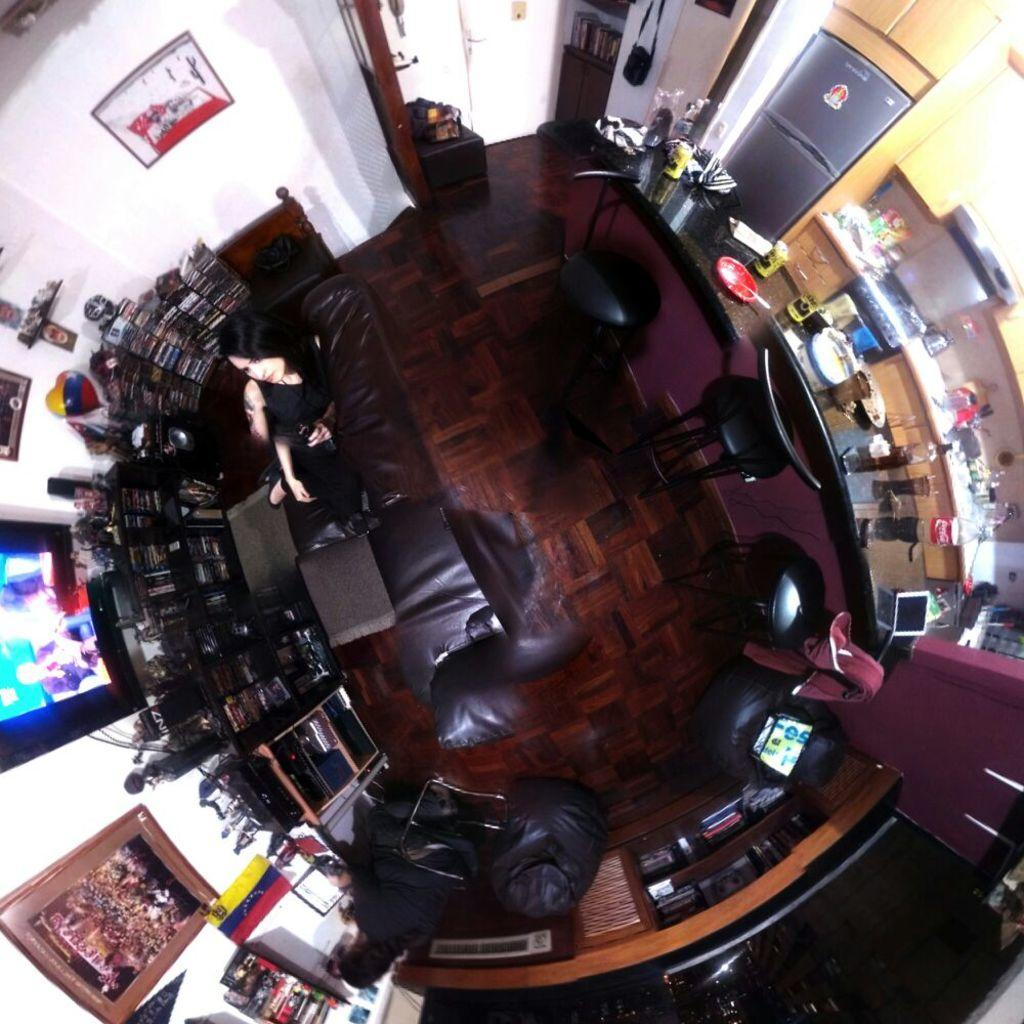What can be seen on the racks in the image? There are books and things on the racks in the image. What is on the wall in the image? There are pictures on the wall in the image. What is on the table in the image? There are objects on the table in the image. What is in front of the table in the image? There are chairs in front of the table in the image. Who or what is present in the image? There is a person in the image. What type of seating is available in the image? There is a couch in the image. What type of crime is being committed in the image? There is no crime being committed in the image; it features racks with books, pictures on the wall, a table with objects, chairs, a couch, and a person. Is there a door visible in the image? There is no door mentioned in the provided facts, so we cannot determine if a door is present in the image. 